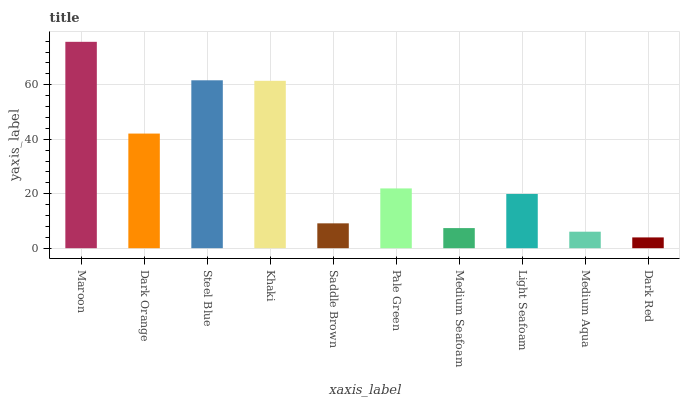Is Dark Red the minimum?
Answer yes or no. Yes. Is Maroon the maximum?
Answer yes or no. Yes. Is Dark Orange the minimum?
Answer yes or no. No. Is Dark Orange the maximum?
Answer yes or no. No. Is Maroon greater than Dark Orange?
Answer yes or no. Yes. Is Dark Orange less than Maroon?
Answer yes or no. Yes. Is Dark Orange greater than Maroon?
Answer yes or no. No. Is Maroon less than Dark Orange?
Answer yes or no. No. Is Pale Green the high median?
Answer yes or no. Yes. Is Light Seafoam the low median?
Answer yes or no. Yes. Is Khaki the high median?
Answer yes or no. No. Is Medium Seafoam the low median?
Answer yes or no. No. 